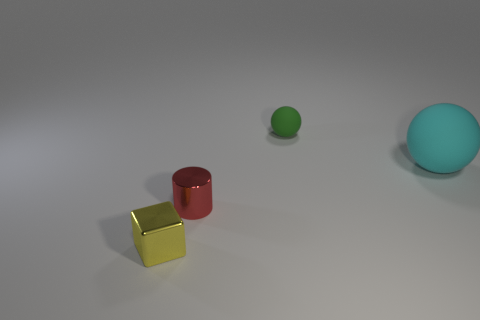Can you describe the shapes and their relative positions in this image? Certainly! In the image, there are four distinct shapes placed on a flat surface. From left to right, we have a yellow cube and a red cylinder at the forefront. Slightly behind them and to the right, there is a tiny green sphere and further back a larger turquoise sphere. Each shape is separated by a moderate amount of space, indicating no direct interaction between them. 